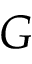Convert formula to latex. <formula><loc_0><loc_0><loc_500><loc_500>G</formula> 